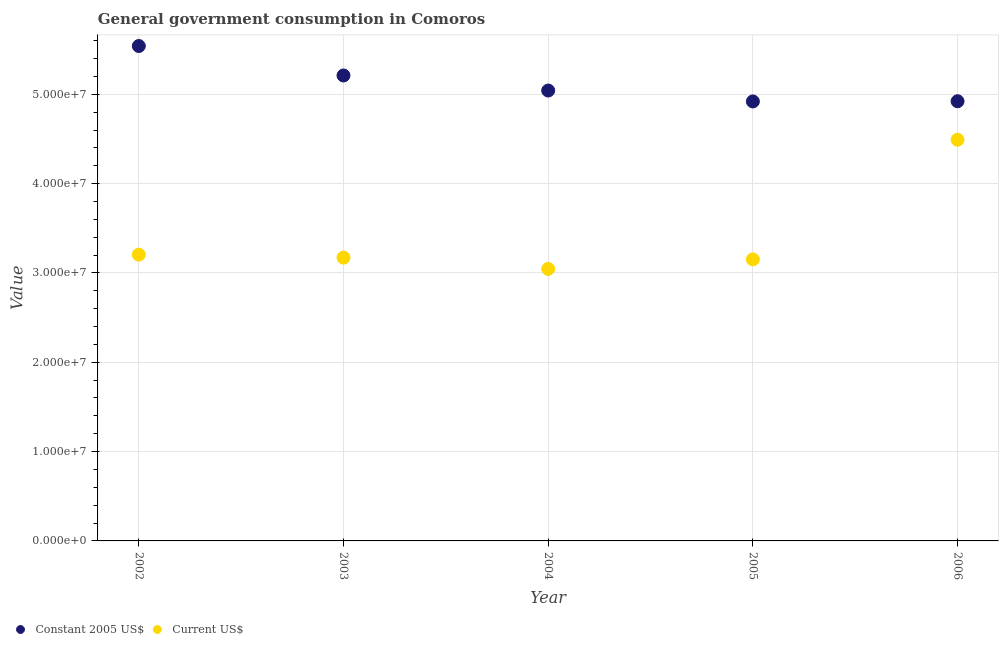Is the number of dotlines equal to the number of legend labels?
Ensure brevity in your answer.  Yes. What is the value consumed in current us$ in 2003?
Ensure brevity in your answer.  3.17e+07. Across all years, what is the maximum value consumed in constant 2005 us$?
Provide a short and direct response. 5.54e+07. Across all years, what is the minimum value consumed in constant 2005 us$?
Your response must be concise. 4.92e+07. In which year was the value consumed in current us$ minimum?
Give a very brief answer. 2004. What is the total value consumed in current us$ in the graph?
Give a very brief answer. 1.71e+08. What is the difference between the value consumed in current us$ in 2004 and that in 2005?
Provide a succinct answer. -1.07e+06. What is the difference between the value consumed in constant 2005 us$ in 2003 and the value consumed in current us$ in 2004?
Offer a terse response. 2.17e+07. What is the average value consumed in current us$ per year?
Offer a terse response. 3.41e+07. In the year 2002, what is the difference between the value consumed in current us$ and value consumed in constant 2005 us$?
Give a very brief answer. -2.34e+07. What is the ratio of the value consumed in constant 2005 us$ in 2002 to that in 2005?
Your answer should be very brief. 1.13. What is the difference between the highest and the second highest value consumed in constant 2005 us$?
Your response must be concise. 3.30e+06. What is the difference between the highest and the lowest value consumed in current us$?
Offer a terse response. 1.45e+07. Is the value consumed in current us$ strictly greater than the value consumed in constant 2005 us$ over the years?
Give a very brief answer. No. Is the value consumed in current us$ strictly less than the value consumed in constant 2005 us$ over the years?
Your response must be concise. Yes. How many years are there in the graph?
Your answer should be very brief. 5. Are the values on the major ticks of Y-axis written in scientific E-notation?
Offer a terse response. Yes. Does the graph contain any zero values?
Ensure brevity in your answer.  No. Where does the legend appear in the graph?
Make the answer very short. Bottom left. How many legend labels are there?
Offer a terse response. 2. How are the legend labels stacked?
Your answer should be very brief. Horizontal. What is the title of the graph?
Make the answer very short. General government consumption in Comoros. Does "Non-resident workers" appear as one of the legend labels in the graph?
Give a very brief answer. No. What is the label or title of the Y-axis?
Give a very brief answer. Value. What is the Value of Constant 2005 US$ in 2002?
Provide a short and direct response. 5.54e+07. What is the Value of Current US$ in 2002?
Provide a succinct answer. 3.20e+07. What is the Value in Constant 2005 US$ in 2003?
Offer a terse response. 5.21e+07. What is the Value of Current US$ in 2003?
Give a very brief answer. 3.17e+07. What is the Value in Constant 2005 US$ in 2004?
Give a very brief answer. 5.04e+07. What is the Value in Current US$ in 2004?
Provide a succinct answer. 3.04e+07. What is the Value of Constant 2005 US$ in 2005?
Give a very brief answer. 4.92e+07. What is the Value in Current US$ in 2005?
Your response must be concise. 3.15e+07. What is the Value in Constant 2005 US$ in 2006?
Your answer should be very brief. 4.92e+07. What is the Value of Current US$ in 2006?
Provide a succinct answer. 4.49e+07. Across all years, what is the maximum Value in Constant 2005 US$?
Give a very brief answer. 5.54e+07. Across all years, what is the maximum Value of Current US$?
Keep it short and to the point. 4.49e+07. Across all years, what is the minimum Value in Constant 2005 US$?
Give a very brief answer. 4.92e+07. Across all years, what is the minimum Value in Current US$?
Give a very brief answer. 3.04e+07. What is the total Value of Constant 2005 US$ in the graph?
Make the answer very short. 2.56e+08. What is the total Value of Current US$ in the graph?
Your response must be concise. 1.71e+08. What is the difference between the Value of Constant 2005 US$ in 2002 and that in 2003?
Your answer should be compact. 3.30e+06. What is the difference between the Value of Current US$ in 2002 and that in 2003?
Offer a very short reply. 3.36e+05. What is the difference between the Value of Constant 2005 US$ in 2002 and that in 2004?
Your answer should be very brief. 4.98e+06. What is the difference between the Value in Current US$ in 2002 and that in 2004?
Offer a very short reply. 1.60e+06. What is the difference between the Value in Constant 2005 US$ in 2002 and that in 2005?
Offer a very short reply. 6.20e+06. What is the difference between the Value in Current US$ in 2002 and that in 2005?
Provide a succinct answer. 5.29e+05. What is the difference between the Value of Constant 2005 US$ in 2002 and that in 2006?
Your answer should be compact. 6.18e+06. What is the difference between the Value in Current US$ in 2002 and that in 2006?
Your answer should be compact. -1.29e+07. What is the difference between the Value in Constant 2005 US$ in 2003 and that in 2004?
Ensure brevity in your answer.  1.69e+06. What is the difference between the Value in Current US$ in 2003 and that in 2004?
Offer a terse response. 1.26e+06. What is the difference between the Value of Constant 2005 US$ in 2003 and that in 2005?
Offer a terse response. 2.91e+06. What is the difference between the Value in Current US$ in 2003 and that in 2005?
Give a very brief answer. 1.93e+05. What is the difference between the Value in Constant 2005 US$ in 2003 and that in 2006?
Provide a succinct answer. 2.88e+06. What is the difference between the Value in Current US$ in 2003 and that in 2006?
Provide a short and direct response. -1.32e+07. What is the difference between the Value of Constant 2005 US$ in 2004 and that in 2005?
Keep it short and to the point. 1.22e+06. What is the difference between the Value in Current US$ in 2004 and that in 2005?
Make the answer very short. -1.07e+06. What is the difference between the Value in Constant 2005 US$ in 2004 and that in 2006?
Provide a succinct answer. 1.20e+06. What is the difference between the Value in Current US$ in 2004 and that in 2006?
Offer a very short reply. -1.45e+07. What is the difference between the Value of Constant 2005 US$ in 2005 and that in 2006?
Your answer should be compact. -2.12e+04. What is the difference between the Value of Current US$ in 2005 and that in 2006?
Your response must be concise. -1.34e+07. What is the difference between the Value in Constant 2005 US$ in 2002 and the Value in Current US$ in 2003?
Your answer should be very brief. 2.37e+07. What is the difference between the Value of Constant 2005 US$ in 2002 and the Value of Current US$ in 2004?
Keep it short and to the point. 2.50e+07. What is the difference between the Value in Constant 2005 US$ in 2002 and the Value in Current US$ in 2005?
Keep it short and to the point. 2.39e+07. What is the difference between the Value of Constant 2005 US$ in 2002 and the Value of Current US$ in 2006?
Offer a terse response. 1.05e+07. What is the difference between the Value in Constant 2005 US$ in 2003 and the Value in Current US$ in 2004?
Offer a terse response. 2.17e+07. What is the difference between the Value in Constant 2005 US$ in 2003 and the Value in Current US$ in 2005?
Your answer should be compact. 2.06e+07. What is the difference between the Value of Constant 2005 US$ in 2003 and the Value of Current US$ in 2006?
Offer a terse response. 7.19e+06. What is the difference between the Value of Constant 2005 US$ in 2004 and the Value of Current US$ in 2005?
Your answer should be very brief. 1.89e+07. What is the difference between the Value in Constant 2005 US$ in 2004 and the Value in Current US$ in 2006?
Ensure brevity in your answer.  5.51e+06. What is the difference between the Value of Constant 2005 US$ in 2005 and the Value of Current US$ in 2006?
Your response must be concise. 4.29e+06. What is the average Value in Constant 2005 US$ per year?
Give a very brief answer. 5.13e+07. What is the average Value of Current US$ per year?
Offer a terse response. 3.41e+07. In the year 2002, what is the difference between the Value of Constant 2005 US$ and Value of Current US$?
Your response must be concise. 2.34e+07. In the year 2003, what is the difference between the Value of Constant 2005 US$ and Value of Current US$?
Ensure brevity in your answer.  2.04e+07. In the year 2004, what is the difference between the Value in Constant 2005 US$ and Value in Current US$?
Provide a succinct answer. 2.00e+07. In the year 2005, what is the difference between the Value of Constant 2005 US$ and Value of Current US$?
Your answer should be compact. 1.77e+07. In the year 2006, what is the difference between the Value of Constant 2005 US$ and Value of Current US$?
Give a very brief answer. 4.31e+06. What is the ratio of the Value in Constant 2005 US$ in 2002 to that in 2003?
Make the answer very short. 1.06. What is the ratio of the Value of Current US$ in 2002 to that in 2003?
Keep it short and to the point. 1.01. What is the ratio of the Value in Constant 2005 US$ in 2002 to that in 2004?
Give a very brief answer. 1.1. What is the ratio of the Value of Current US$ in 2002 to that in 2004?
Offer a very short reply. 1.05. What is the ratio of the Value of Constant 2005 US$ in 2002 to that in 2005?
Offer a terse response. 1.13. What is the ratio of the Value in Current US$ in 2002 to that in 2005?
Offer a very short reply. 1.02. What is the ratio of the Value of Constant 2005 US$ in 2002 to that in 2006?
Offer a terse response. 1.13. What is the ratio of the Value in Current US$ in 2002 to that in 2006?
Make the answer very short. 0.71. What is the ratio of the Value of Constant 2005 US$ in 2003 to that in 2004?
Your answer should be very brief. 1.03. What is the ratio of the Value in Current US$ in 2003 to that in 2004?
Give a very brief answer. 1.04. What is the ratio of the Value of Constant 2005 US$ in 2003 to that in 2005?
Offer a terse response. 1.06. What is the ratio of the Value in Constant 2005 US$ in 2003 to that in 2006?
Your answer should be very brief. 1.06. What is the ratio of the Value of Current US$ in 2003 to that in 2006?
Your answer should be very brief. 0.71. What is the ratio of the Value in Constant 2005 US$ in 2004 to that in 2005?
Provide a short and direct response. 1.02. What is the ratio of the Value of Current US$ in 2004 to that in 2005?
Your answer should be compact. 0.97. What is the ratio of the Value in Constant 2005 US$ in 2004 to that in 2006?
Provide a succinct answer. 1.02. What is the ratio of the Value of Current US$ in 2004 to that in 2006?
Ensure brevity in your answer.  0.68. What is the ratio of the Value of Constant 2005 US$ in 2005 to that in 2006?
Ensure brevity in your answer.  1. What is the ratio of the Value of Current US$ in 2005 to that in 2006?
Your answer should be very brief. 0.7. What is the difference between the highest and the second highest Value of Constant 2005 US$?
Give a very brief answer. 3.30e+06. What is the difference between the highest and the second highest Value in Current US$?
Your response must be concise. 1.29e+07. What is the difference between the highest and the lowest Value of Constant 2005 US$?
Provide a short and direct response. 6.20e+06. What is the difference between the highest and the lowest Value in Current US$?
Your answer should be very brief. 1.45e+07. 